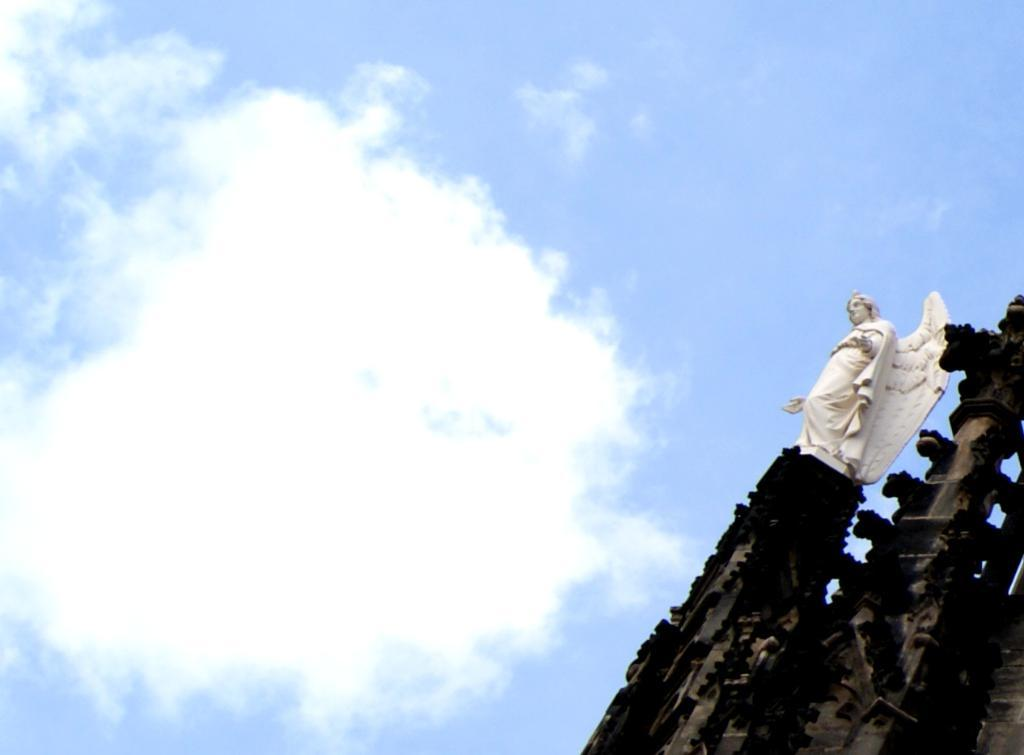What is the main subject of the image? There is a statue with wings in the image. Where is the statue located? The statue is placed on top of a building. What can be seen in the background of the image? The sky is visible in the background of the image. How would you describe the weather based on the sky in the image? The sky appears to be cloudy, which might suggest overcast or potentially rainy weather. Can you see the crown on the statue's head in the image? There is no crown mentioned or visible on the statue in the image. Is there a volleyball game happening in the background of the image? There is no volleyball game or any reference to volleyball in the image. 